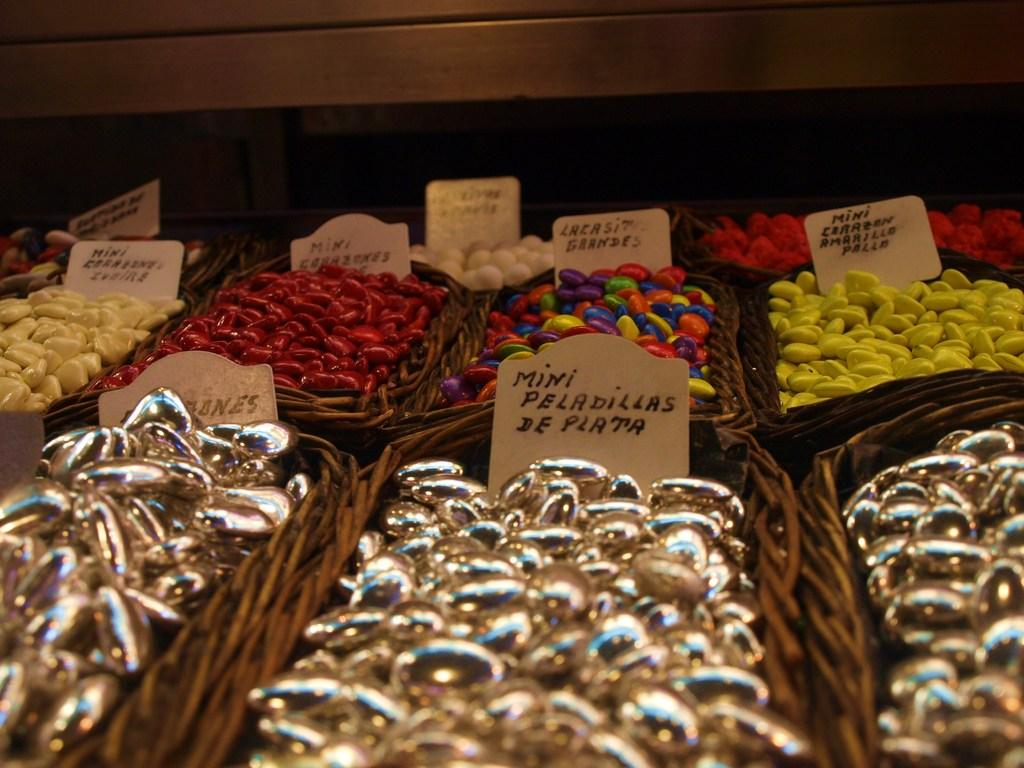What can be seen in the image? There are objects in the image. How are the objects arranged in the image? The objects are in trays. Where are the trays located in the image? The trays are located in the center of the image. What type of arch can be seen in the image? There is no arch present in the image. What company is responsible for the objects in the image? The image does not provide information about the company responsible for the objects. 